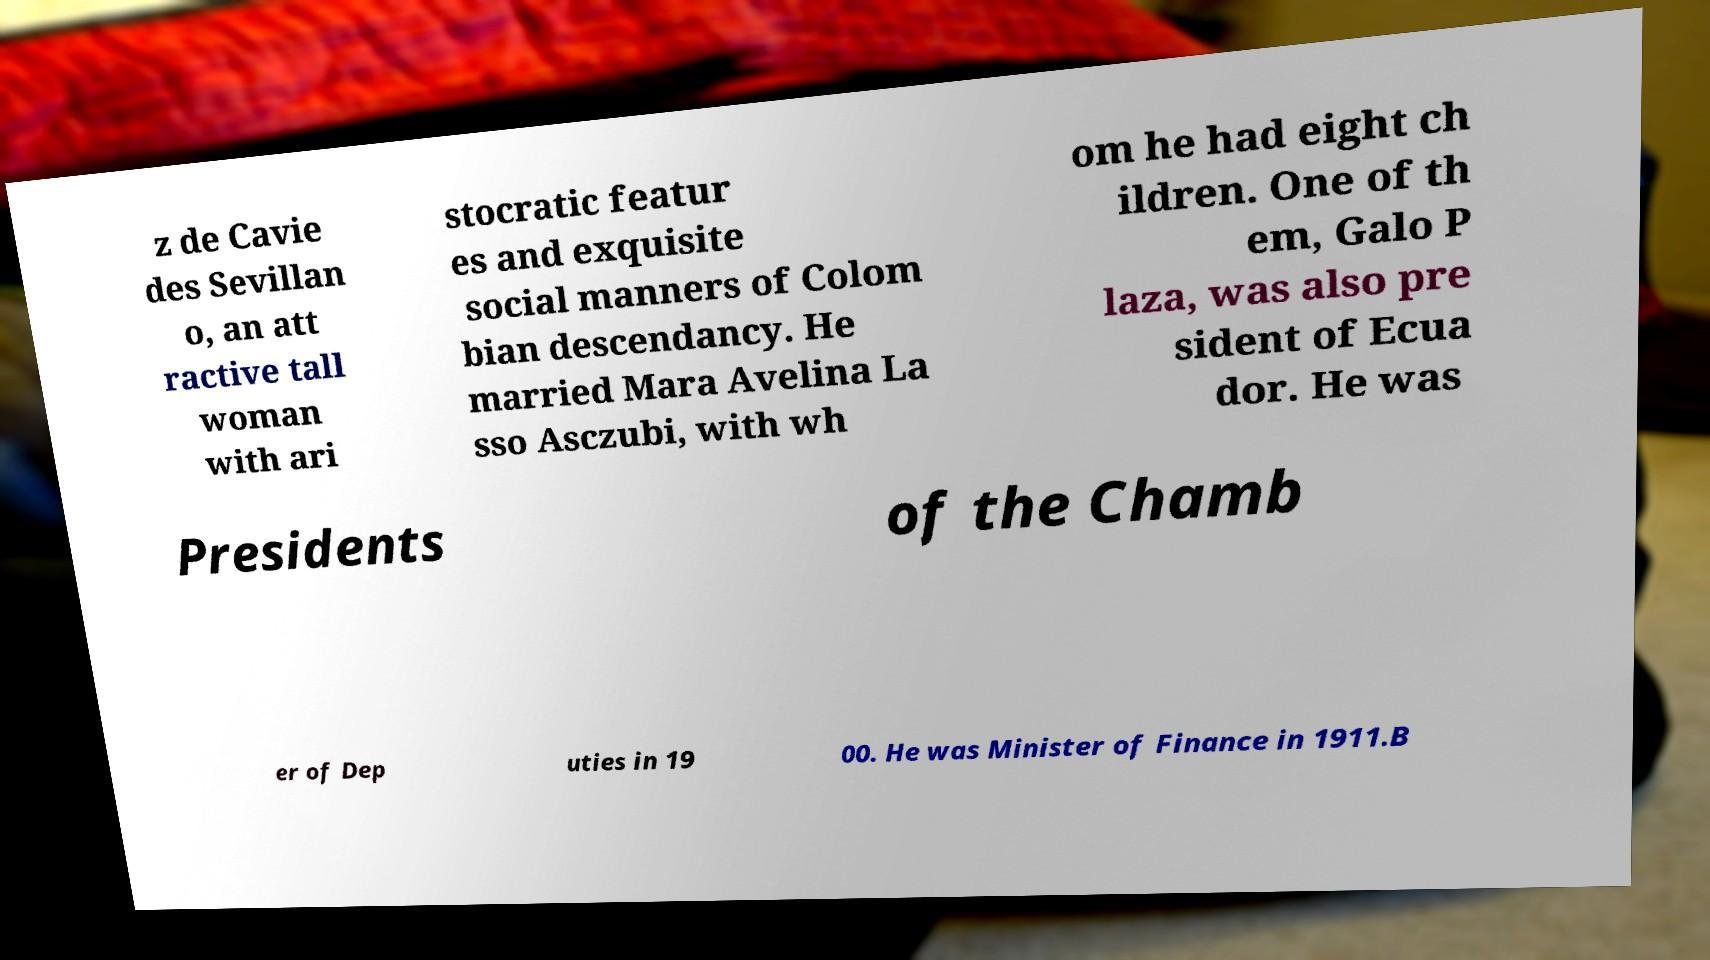Can you accurately transcribe the text from the provided image for me? z de Cavie des Sevillan o, an att ractive tall woman with ari stocratic featur es and exquisite social manners of Colom bian descendancy. He married Mara Avelina La sso Asczubi, with wh om he had eight ch ildren. One of th em, Galo P laza, was also pre sident of Ecua dor. He was Presidents of the Chamb er of Dep uties in 19 00. He was Minister of Finance in 1911.B 